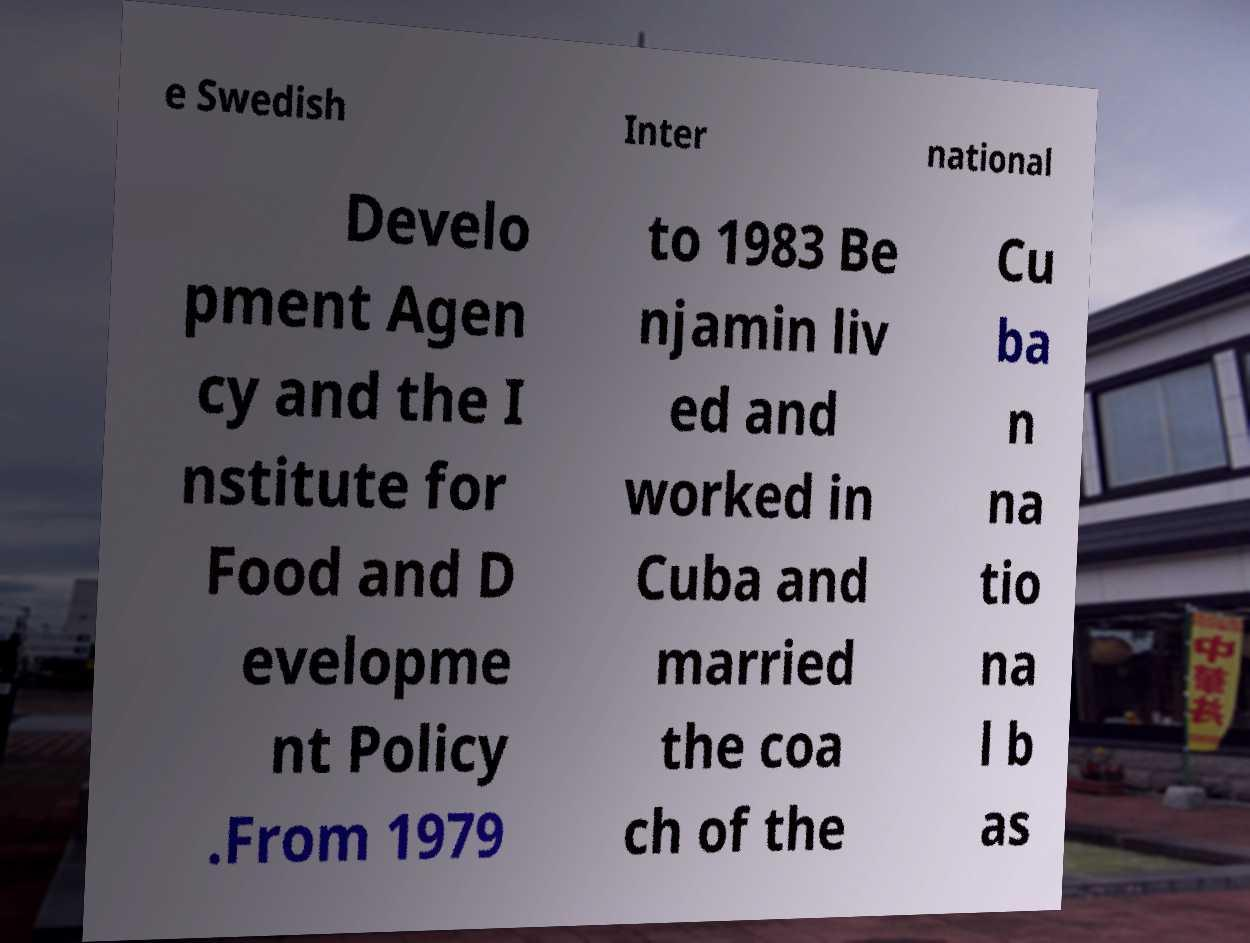There's text embedded in this image that I need extracted. Can you transcribe it verbatim? e Swedish Inter national Develo pment Agen cy and the I nstitute for Food and D evelopme nt Policy .From 1979 to 1983 Be njamin liv ed and worked in Cuba and married the coa ch of the Cu ba n na tio na l b as 